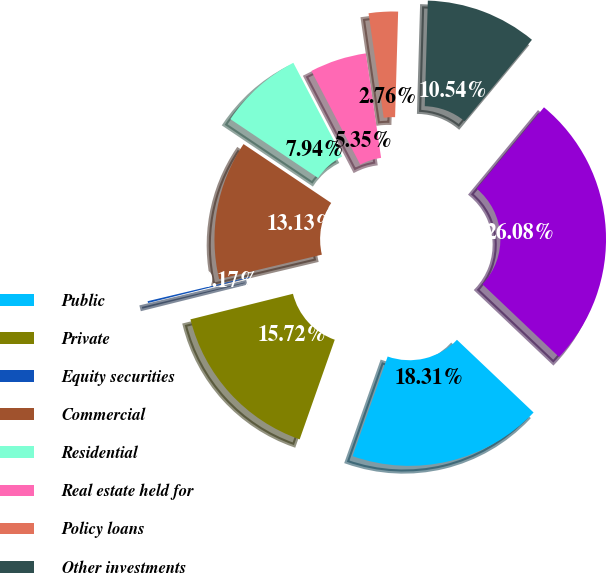Convert chart. <chart><loc_0><loc_0><loc_500><loc_500><pie_chart><fcel>Public<fcel>Private<fcel>Equity securities<fcel>Commercial<fcel>Residential<fcel>Real estate held for<fcel>Policy loans<fcel>Other investments<fcel>Total invested assets<nl><fcel>18.31%<fcel>15.72%<fcel>0.17%<fcel>13.13%<fcel>7.94%<fcel>5.35%<fcel>2.76%<fcel>10.54%<fcel>26.08%<nl></chart> 